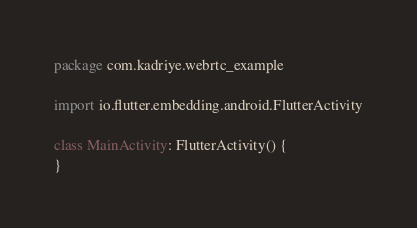Convert code to text. <code><loc_0><loc_0><loc_500><loc_500><_Kotlin_>package com.kadriye.webrtc_example

import io.flutter.embedding.android.FlutterActivity

class MainActivity: FlutterActivity() {
}
</code> 